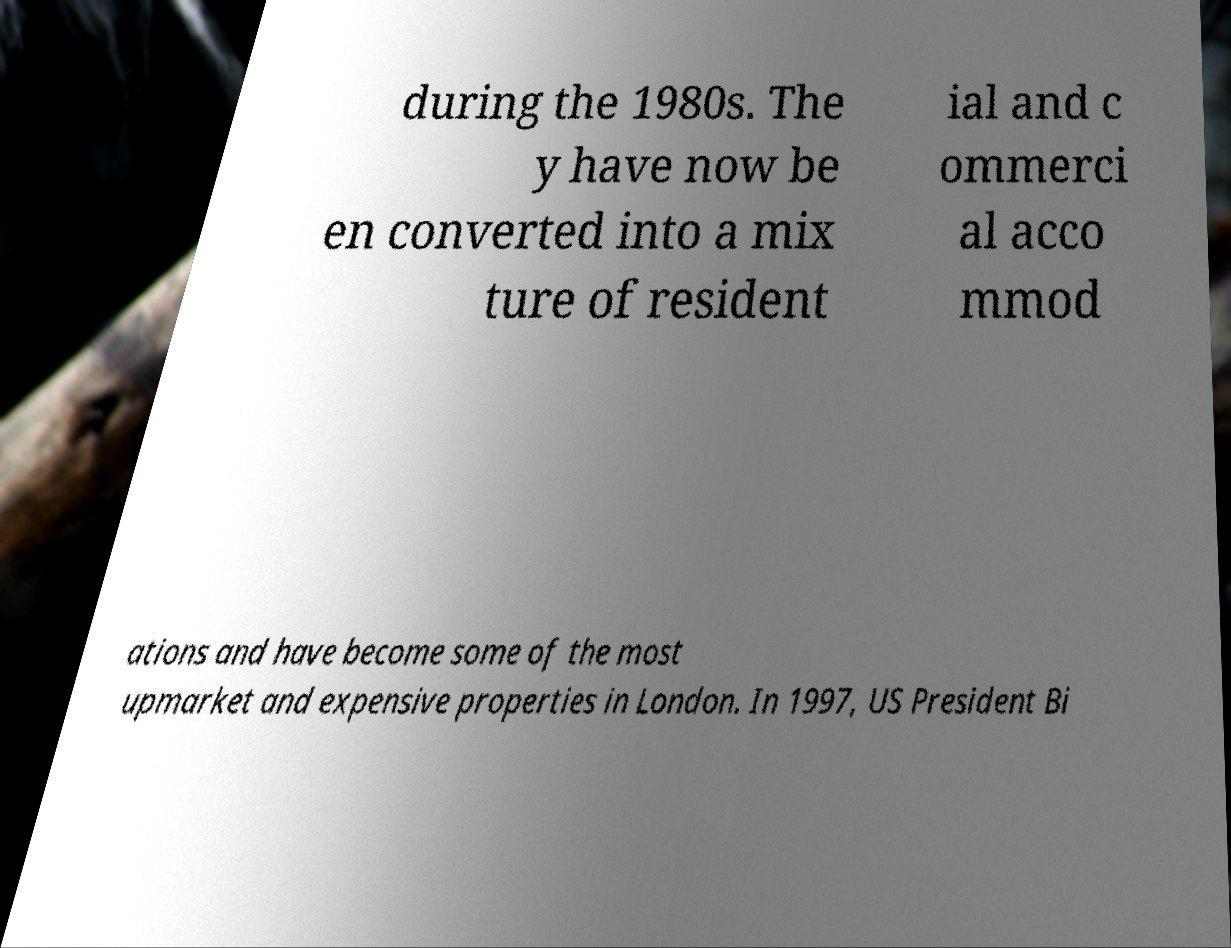Please read and relay the text visible in this image. What does it say? during the 1980s. The y have now be en converted into a mix ture of resident ial and c ommerci al acco mmod ations and have become some of the most upmarket and expensive properties in London. In 1997, US President Bi 